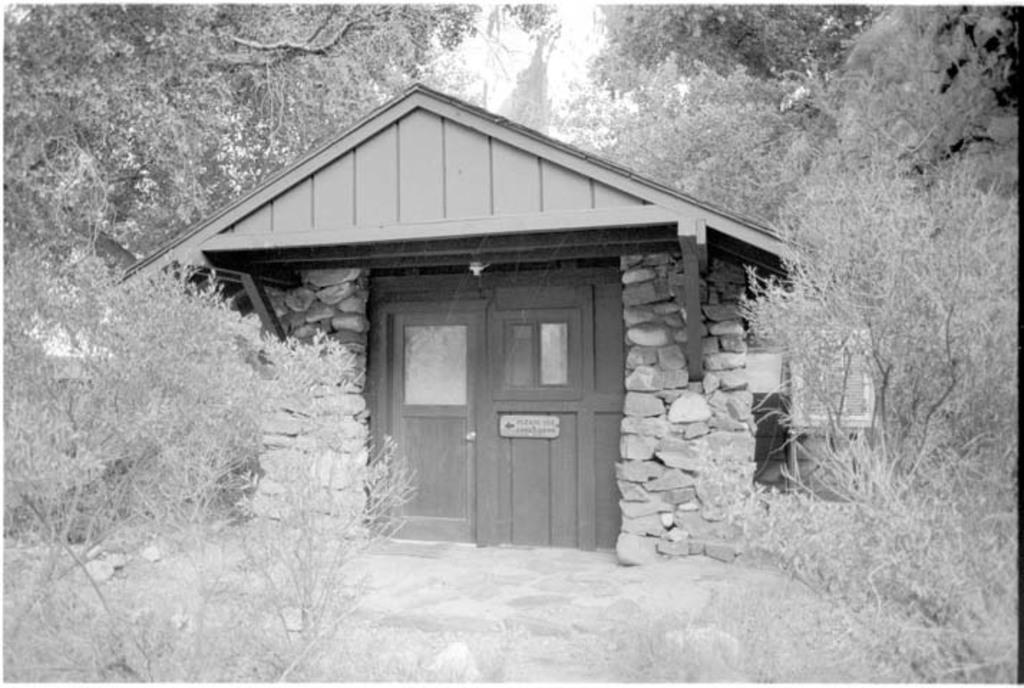What type of structure is present in the image? There is a shack in the image. What other natural elements can be seen in the image? There are plants and trees in the image. How many geese are resting on the bed in the image? There are no geese or beds present in the image. What type of army is depicted in the image? There is no army depicted in the image; it features a shack, plants, and trees. 